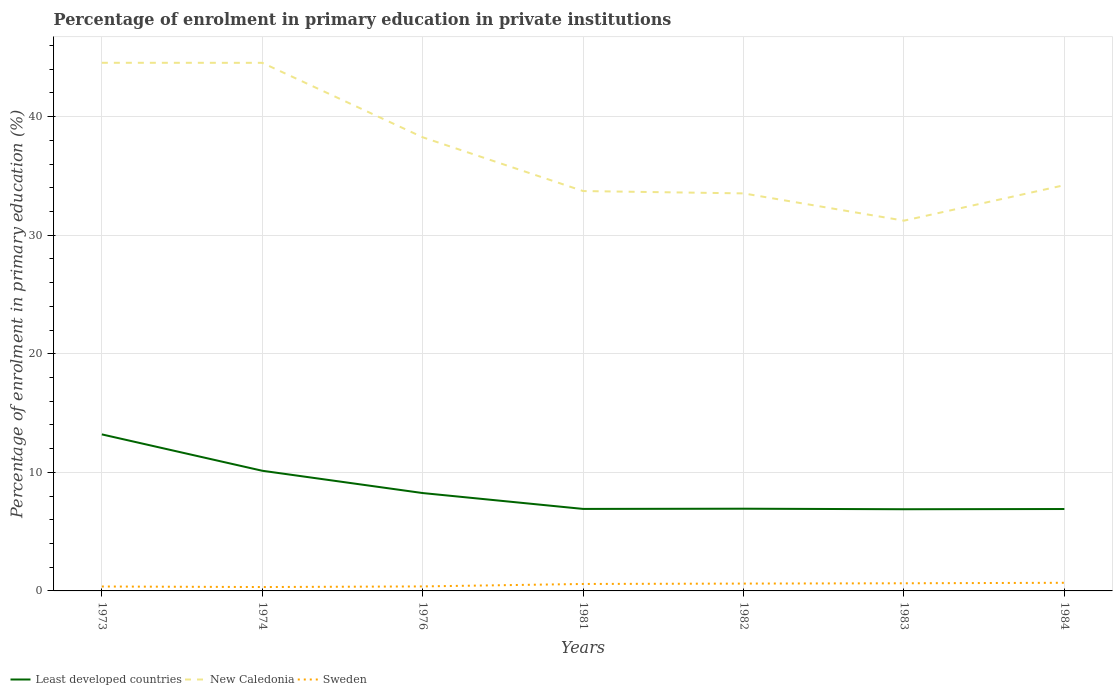Does the line corresponding to Sweden intersect with the line corresponding to New Caledonia?
Offer a very short reply. No. Across all years, what is the maximum percentage of enrolment in primary education in Least developed countries?
Give a very brief answer. 6.89. What is the total percentage of enrolment in primary education in Least developed countries in the graph?
Ensure brevity in your answer.  6.31. What is the difference between the highest and the second highest percentage of enrolment in primary education in Least developed countries?
Offer a terse response. 6.31. Is the percentage of enrolment in primary education in Sweden strictly greater than the percentage of enrolment in primary education in New Caledonia over the years?
Offer a very short reply. Yes. What is the difference between two consecutive major ticks on the Y-axis?
Your response must be concise. 10. Does the graph contain grids?
Your response must be concise. Yes. How many legend labels are there?
Provide a succinct answer. 3. What is the title of the graph?
Provide a succinct answer. Percentage of enrolment in primary education in private institutions. What is the label or title of the Y-axis?
Your answer should be very brief. Percentage of enrolment in primary education (%). What is the Percentage of enrolment in primary education (%) in Least developed countries in 1973?
Give a very brief answer. 13.2. What is the Percentage of enrolment in primary education (%) of New Caledonia in 1973?
Offer a terse response. 44.54. What is the Percentage of enrolment in primary education (%) in Sweden in 1973?
Keep it short and to the point. 0.37. What is the Percentage of enrolment in primary education (%) in Least developed countries in 1974?
Your response must be concise. 10.13. What is the Percentage of enrolment in primary education (%) of New Caledonia in 1974?
Your response must be concise. 44.54. What is the Percentage of enrolment in primary education (%) of Sweden in 1974?
Ensure brevity in your answer.  0.33. What is the Percentage of enrolment in primary education (%) in Least developed countries in 1976?
Make the answer very short. 8.25. What is the Percentage of enrolment in primary education (%) in New Caledonia in 1976?
Give a very brief answer. 38.26. What is the Percentage of enrolment in primary education (%) in Sweden in 1976?
Your answer should be compact. 0.38. What is the Percentage of enrolment in primary education (%) of Least developed countries in 1981?
Your answer should be compact. 6.92. What is the Percentage of enrolment in primary education (%) of New Caledonia in 1981?
Your answer should be very brief. 33.72. What is the Percentage of enrolment in primary education (%) of Sweden in 1981?
Provide a succinct answer. 0.59. What is the Percentage of enrolment in primary education (%) of Least developed countries in 1982?
Make the answer very short. 6.93. What is the Percentage of enrolment in primary education (%) in New Caledonia in 1982?
Provide a short and direct response. 33.53. What is the Percentage of enrolment in primary education (%) in Sweden in 1982?
Your answer should be very brief. 0.62. What is the Percentage of enrolment in primary education (%) of Least developed countries in 1983?
Ensure brevity in your answer.  6.89. What is the Percentage of enrolment in primary education (%) in New Caledonia in 1983?
Your answer should be very brief. 31.23. What is the Percentage of enrolment in primary education (%) of Sweden in 1983?
Provide a succinct answer. 0.64. What is the Percentage of enrolment in primary education (%) of Least developed countries in 1984?
Offer a very short reply. 6.91. What is the Percentage of enrolment in primary education (%) of New Caledonia in 1984?
Ensure brevity in your answer.  34.22. What is the Percentage of enrolment in primary education (%) in Sweden in 1984?
Your response must be concise. 0.69. Across all years, what is the maximum Percentage of enrolment in primary education (%) in Least developed countries?
Give a very brief answer. 13.2. Across all years, what is the maximum Percentage of enrolment in primary education (%) in New Caledonia?
Make the answer very short. 44.54. Across all years, what is the maximum Percentage of enrolment in primary education (%) of Sweden?
Offer a very short reply. 0.69. Across all years, what is the minimum Percentage of enrolment in primary education (%) in Least developed countries?
Provide a succinct answer. 6.89. Across all years, what is the minimum Percentage of enrolment in primary education (%) in New Caledonia?
Give a very brief answer. 31.23. Across all years, what is the minimum Percentage of enrolment in primary education (%) in Sweden?
Make the answer very short. 0.33. What is the total Percentage of enrolment in primary education (%) in Least developed countries in the graph?
Your answer should be very brief. 59.24. What is the total Percentage of enrolment in primary education (%) in New Caledonia in the graph?
Provide a short and direct response. 260.04. What is the total Percentage of enrolment in primary education (%) in Sweden in the graph?
Offer a very short reply. 3.62. What is the difference between the Percentage of enrolment in primary education (%) in Least developed countries in 1973 and that in 1974?
Your answer should be compact. 3.07. What is the difference between the Percentage of enrolment in primary education (%) of New Caledonia in 1973 and that in 1974?
Keep it short and to the point. 0. What is the difference between the Percentage of enrolment in primary education (%) of Sweden in 1973 and that in 1974?
Make the answer very short. 0.05. What is the difference between the Percentage of enrolment in primary education (%) of Least developed countries in 1973 and that in 1976?
Your answer should be very brief. 4.95. What is the difference between the Percentage of enrolment in primary education (%) in New Caledonia in 1973 and that in 1976?
Offer a terse response. 6.28. What is the difference between the Percentage of enrolment in primary education (%) in Sweden in 1973 and that in 1976?
Ensure brevity in your answer.  -0.01. What is the difference between the Percentage of enrolment in primary education (%) of Least developed countries in 1973 and that in 1981?
Your answer should be compact. 6.29. What is the difference between the Percentage of enrolment in primary education (%) of New Caledonia in 1973 and that in 1981?
Give a very brief answer. 10.82. What is the difference between the Percentage of enrolment in primary education (%) of Sweden in 1973 and that in 1981?
Your answer should be very brief. -0.21. What is the difference between the Percentage of enrolment in primary education (%) of Least developed countries in 1973 and that in 1982?
Make the answer very short. 6.27. What is the difference between the Percentage of enrolment in primary education (%) of New Caledonia in 1973 and that in 1982?
Provide a succinct answer. 11.01. What is the difference between the Percentage of enrolment in primary education (%) of Sweden in 1973 and that in 1982?
Give a very brief answer. -0.25. What is the difference between the Percentage of enrolment in primary education (%) of Least developed countries in 1973 and that in 1983?
Provide a short and direct response. 6.31. What is the difference between the Percentage of enrolment in primary education (%) of New Caledonia in 1973 and that in 1983?
Your answer should be compact. 13.31. What is the difference between the Percentage of enrolment in primary education (%) of Sweden in 1973 and that in 1983?
Offer a very short reply. -0.27. What is the difference between the Percentage of enrolment in primary education (%) of Least developed countries in 1973 and that in 1984?
Your answer should be compact. 6.29. What is the difference between the Percentage of enrolment in primary education (%) of New Caledonia in 1973 and that in 1984?
Provide a succinct answer. 10.32. What is the difference between the Percentage of enrolment in primary education (%) in Sweden in 1973 and that in 1984?
Ensure brevity in your answer.  -0.31. What is the difference between the Percentage of enrolment in primary education (%) in Least developed countries in 1974 and that in 1976?
Offer a very short reply. 1.88. What is the difference between the Percentage of enrolment in primary education (%) of New Caledonia in 1974 and that in 1976?
Offer a terse response. 6.28. What is the difference between the Percentage of enrolment in primary education (%) of Sweden in 1974 and that in 1976?
Your answer should be very brief. -0.05. What is the difference between the Percentage of enrolment in primary education (%) of Least developed countries in 1974 and that in 1981?
Ensure brevity in your answer.  3.22. What is the difference between the Percentage of enrolment in primary education (%) of New Caledonia in 1974 and that in 1981?
Offer a terse response. 10.81. What is the difference between the Percentage of enrolment in primary education (%) in Sweden in 1974 and that in 1981?
Your response must be concise. -0.26. What is the difference between the Percentage of enrolment in primary education (%) in Least developed countries in 1974 and that in 1982?
Make the answer very short. 3.2. What is the difference between the Percentage of enrolment in primary education (%) of New Caledonia in 1974 and that in 1982?
Give a very brief answer. 11.01. What is the difference between the Percentage of enrolment in primary education (%) of Sweden in 1974 and that in 1982?
Offer a terse response. -0.29. What is the difference between the Percentage of enrolment in primary education (%) of Least developed countries in 1974 and that in 1983?
Provide a succinct answer. 3.25. What is the difference between the Percentage of enrolment in primary education (%) of New Caledonia in 1974 and that in 1983?
Ensure brevity in your answer.  13.31. What is the difference between the Percentage of enrolment in primary education (%) of Sweden in 1974 and that in 1983?
Provide a succinct answer. -0.32. What is the difference between the Percentage of enrolment in primary education (%) of Least developed countries in 1974 and that in 1984?
Your response must be concise. 3.23. What is the difference between the Percentage of enrolment in primary education (%) in New Caledonia in 1974 and that in 1984?
Offer a terse response. 10.32. What is the difference between the Percentage of enrolment in primary education (%) in Sweden in 1974 and that in 1984?
Provide a succinct answer. -0.36. What is the difference between the Percentage of enrolment in primary education (%) of Least developed countries in 1976 and that in 1981?
Offer a very short reply. 1.34. What is the difference between the Percentage of enrolment in primary education (%) in New Caledonia in 1976 and that in 1981?
Offer a very short reply. 4.54. What is the difference between the Percentage of enrolment in primary education (%) in Sweden in 1976 and that in 1981?
Give a very brief answer. -0.21. What is the difference between the Percentage of enrolment in primary education (%) in Least developed countries in 1976 and that in 1982?
Provide a short and direct response. 1.32. What is the difference between the Percentage of enrolment in primary education (%) of New Caledonia in 1976 and that in 1982?
Offer a very short reply. 4.73. What is the difference between the Percentage of enrolment in primary education (%) of Sweden in 1976 and that in 1982?
Make the answer very short. -0.24. What is the difference between the Percentage of enrolment in primary education (%) of Least developed countries in 1976 and that in 1983?
Give a very brief answer. 1.36. What is the difference between the Percentage of enrolment in primary education (%) in New Caledonia in 1976 and that in 1983?
Your response must be concise. 7.03. What is the difference between the Percentage of enrolment in primary education (%) of Sweden in 1976 and that in 1983?
Provide a succinct answer. -0.26. What is the difference between the Percentage of enrolment in primary education (%) of Least developed countries in 1976 and that in 1984?
Offer a terse response. 1.35. What is the difference between the Percentage of enrolment in primary education (%) in New Caledonia in 1976 and that in 1984?
Provide a succinct answer. 4.04. What is the difference between the Percentage of enrolment in primary education (%) of Sweden in 1976 and that in 1984?
Provide a short and direct response. -0.31. What is the difference between the Percentage of enrolment in primary education (%) in Least developed countries in 1981 and that in 1982?
Keep it short and to the point. -0.02. What is the difference between the Percentage of enrolment in primary education (%) of New Caledonia in 1981 and that in 1982?
Offer a terse response. 0.2. What is the difference between the Percentage of enrolment in primary education (%) of Sweden in 1981 and that in 1982?
Your answer should be very brief. -0.03. What is the difference between the Percentage of enrolment in primary education (%) of Least developed countries in 1981 and that in 1983?
Your answer should be very brief. 0.03. What is the difference between the Percentage of enrolment in primary education (%) in New Caledonia in 1981 and that in 1983?
Offer a terse response. 2.5. What is the difference between the Percentage of enrolment in primary education (%) in Sweden in 1981 and that in 1983?
Offer a very short reply. -0.06. What is the difference between the Percentage of enrolment in primary education (%) of Least developed countries in 1981 and that in 1984?
Offer a terse response. 0.01. What is the difference between the Percentage of enrolment in primary education (%) of New Caledonia in 1981 and that in 1984?
Offer a very short reply. -0.5. What is the difference between the Percentage of enrolment in primary education (%) of Sweden in 1981 and that in 1984?
Your answer should be compact. -0.1. What is the difference between the Percentage of enrolment in primary education (%) in Least developed countries in 1982 and that in 1983?
Offer a terse response. 0.04. What is the difference between the Percentage of enrolment in primary education (%) of New Caledonia in 1982 and that in 1983?
Keep it short and to the point. 2.3. What is the difference between the Percentage of enrolment in primary education (%) in Sweden in 1982 and that in 1983?
Your answer should be very brief. -0.03. What is the difference between the Percentage of enrolment in primary education (%) of Least developed countries in 1982 and that in 1984?
Offer a very short reply. 0.03. What is the difference between the Percentage of enrolment in primary education (%) of New Caledonia in 1982 and that in 1984?
Your response must be concise. -0.69. What is the difference between the Percentage of enrolment in primary education (%) in Sweden in 1982 and that in 1984?
Your answer should be very brief. -0.07. What is the difference between the Percentage of enrolment in primary education (%) of Least developed countries in 1983 and that in 1984?
Give a very brief answer. -0.02. What is the difference between the Percentage of enrolment in primary education (%) in New Caledonia in 1983 and that in 1984?
Your response must be concise. -2.99. What is the difference between the Percentage of enrolment in primary education (%) of Sweden in 1983 and that in 1984?
Offer a terse response. -0.04. What is the difference between the Percentage of enrolment in primary education (%) of Least developed countries in 1973 and the Percentage of enrolment in primary education (%) of New Caledonia in 1974?
Keep it short and to the point. -31.34. What is the difference between the Percentage of enrolment in primary education (%) in Least developed countries in 1973 and the Percentage of enrolment in primary education (%) in Sweden in 1974?
Provide a short and direct response. 12.87. What is the difference between the Percentage of enrolment in primary education (%) in New Caledonia in 1973 and the Percentage of enrolment in primary education (%) in Sweden in 1974?
Make the answer very short. 44.21. What is the difference between the Percentage of enrolment in primary education (%) of Least developed countries in 1973 and the Percentage of enrolment in primary education (%) of New Caledonia in 1976?
Your response must be concise. -25.06. What is the difference between the Percentage of enrolment in primary education (%) in Least developed countries in 1973 and the Percentage of enrolment in primary education (%) in Sweden in 1976?
Provide a short and direct response. 12.82. What is the difference between the Percentage of enrolment in primary education (%) in New Caledonia in 1973 and the Percentage of enrolment in primary education (%) in Sweden in 1976?
Offer a very short reply. 44.16. What is the difference between the Percentage of enrolment in primary education (%) of Least developed countries in 1973 and the Percentage of enrolment in primary education (%) of New Caledonia in 1981?
Your answer should be compact. -20.52. What is the difference between the Percentage of enrolment in primary education (%) in Least developed countries in 1973 and the Percentage of enrolment in primary education (%) in Sweden in 1981?
Offer a terse response. 12.62. What is the difference between the Percentage of enrolment in primary education (%) of New Caledonia in 1973 and the Percentage of enrolment in primary education (%) of Sweden in 1981?
Provide a succinct answer. 43.95. What is the difference between the Percentage of enrolment in primary education (%) of Least developed countries in 1973 and the Percentage of enrolment in primary education (%) of New Caledonia in 1982?
Offer a terse response. -20.32. What is the difference between the Percentage of enrolment in primary education (%) of Least developed countries in 1973 and the Percentage of enrolment in primary education (%) of Sweden in 1982?
Give a very brief answer. 12.58. What is the difference between the Percentage of enrolment in primary education (%) of New Caledonia in 1973 and the Percentage of enrolment in primary education (%) of Sweden in 1982?
Your response must be concise. 43.92. What is the difference between the Percentage of enrolment in primary education (%) in Least developed countries in 1973 and the Percentage of enrolment in primary education (%) in New Caledonia in 1983?
Offer a very short reply. -18.02. What is the difference between the Percentage of enrolment in primary education (%) of Least developed countries in 1973 and the Percentage of enrolment in primary education (%) of Sweden in 1983?
Your response must be concise. 12.56. What is the difference between the Percentage of enrolment in primary education (%) in New Caledonia in 1973 and the Percentage of enrolment in primary education (%) in Sweden in 1983?
Offer a terse response. 43.9. What is the difference between the Percentage of enrolment in primary education (%) in Least developed countries in 1973 and the Percentage of enrolment in primary education (%) in New Caledonia in 1984?
Your answer should be very brief. -21.02. What is the difference between the Percentage of enrolment in primary education (%) of Least developed countries in 1973 and the Percentage of enrolment in primary education (%) of Sweden in 1984?
Offer a very short reply. 12.52. What is the difference between the Percentage of enrolment in primary education (%) of New Caledonia in 1973 and the Percentage of enrolment in primary education (%) of Sweden in 1984?
Provide a succinct answer. 43.86. What is the difference between the Percentage of enrolment in primary education (%) of Least developed countries in 1974 and the Percentage of enrolment in primary education (%) of New Caledonia in 1976?
Your answer should be compact. -28.12. What is the difference between the Percentage of enrolment in primary education (%) of Least developed countries in 1974 and the Percentage of enrolment in primary education (%) of Sweden in 1976?
Make the answer very short. 9.76. What is the difference between the Percentage of enrolment in primary education (%) in New Caledonia in 1974 and the Percentage of enrolment in primary education (%) in Sweden in 1976?
Make the answer very short. 44.16. What is the difference between the Percentage of enrolment in primary education (%) in Least developed countries in 1974 and the Percentage of enrolment in primary education (%) in New Caledonia in 1981?
Give a very brief answer. -23.59. What is the difference between the Percentage of enrolment in primary education (%) of Least developed countries in 1974 and the Percentage of enrolment in primary education (%) of Sweden in 1981?
Your answer should be compact. 9.55. What is the difference between the Percentage of enrolment in primary education (%) in New Caledonia in 1974 and the Percentage of enrolment in primary education (%) in Sweden in 1981?
Keep it short and to the point. 43.95. What is the difference between the Percentage of enrolment in primary education (%) of Least developed countries in 1974 and the Percentage of enrolment in primary education (%) of New Caledonia in 1982?
Offer a very short reply. -23.39. What is the difference between the Percentage of enrolment in primary education (%) of Least developed countries in 1974 and the Percentage of enrolment in primary education (%) of Sweden in 1982?
Make the answer very short. 9.52. What is the difference between the Percentage of enrolment in primary education (%) in New Caledonia in 1974 and the Percentage of enrolment in primary education (%) in Sweden in 1982?
Your response must be concise. 43.92. What is the difference between the Percentage of enrolment in primary education (%) of Least developed countries in 1974 and the Percentage of enrolment in primary education (%) of New Caledonia in 1983?
Provide a succinct answer. -21.09. What is the difference between the Percentage of enrolment in primary education (%) in Least developed countries in 1974 and the Percentage of enrolment in primary education (%) in Sweden in 1983?
Offer a terse response. 9.49. What is the difference between the Percentage of enrolment in primary education (%) of New Caledonia in 1974 and the Percentage of enrolment in primary education (%) of Sweden in 1983?
Offer a terse response. 43.89. What is the difference between the Percentage of enrolment in primary education (%) of Least developed countries in 1974 and the Percentage of enrolment in primary education (%) of New Caledonia in 1984?
Offer a very short reply. -24.08. What is the difference between the Percentage of enrolment in primary education (%) in Least developed countries in 1974 and the Percentage of enrolment in primary education (%) in Sweden in 1984?
Offer a very short reply. 9.45. What is the difference between the Percentage of enrolment in primary education (%) in New Caledonia in 1974 and the Percentage of enrolment in primary education (%) in Sweden in 1984?
Give a very brief answer. 43.85. What is the difference between the Percentage of enrolment in primary education (%) in Least developed countries in 1976 and the Percentage of enrolment in primary education (%) in New Caledonia in 1981?
Provide a short and direct response. -25.47. What is the difference between the Percentage of enrolment in primary education (%) of Least developed countries in 1976 and the Percentage of enrolment in primary education (%) of Sweden in 1981?
Give a very brief answer. 7.67. What is the difference between the Percentage of enrolment in primary education (%) of New Caledonia in 1976 and the Percentage of enrolment in primary education (%) of Sweden in 1981?
Your answer should be very brief. 37.67. What is the difference between the Percentage of enrolment in primary education (%) in Least developed countries in 1976 and the Percentage of enrolment in primary education (%) in New Caledonia in 1982?
Give a very brief answer. -25.27. What is the difference between the Percentage of enrolment in primary education (%) in Least developed countries in 1976 and the Percentage of enrolment in primary education (%) in Sweden in 1982?
Give a very brief answer. 7.63. What is the difference between the Percentage of enrolment in primary education (%) of New Caledonia in 1976 and the Percentage of enrolment in primary education (%) of Sweden in 1982?
Your response must be concise. 37.64. What is the difference between the Percentage of enrolment in primary education (%) of Least developed countries in 1976 and the Percentage of enrolment in primary education (%) of New Caledonia in 1983?
Offer a terse response. -22.97. What is the difference between the Percentage of enrolment in primary education (%) in Least developed countries in 1976 and the Percentage of enrolment in primary education (%) in Sweden in 1983?
Your answer should be compact. 7.61. What is the difference between the Percentage of enrolment in primary education (%) in New Caledonia in 1976 and the Percentage of enrolment in primary education (%) in Sweden in 1983?
Offer a very short reply. 37.62. What is the difference between the Percentage of enrolment in primary education (%) of Least developed countries in 1976 and the Percentage of enrolment in primary education (%) of New Caledonia in 1984?
Provide a succinct answer. -25.97. What is the difference between the Percentage of enrolment in primary education (%) of Least developed countries in 1976 and the Percentage of enrolment in primary education (%) of Sweden in 1984?
Make the answer very short. 7.57. What is the difference between the Percentage of enrolment in primary education (%) of New Caledonia in 1976 and the Percentage of enrolment in primary education (%) of Sweden in 1984?
Keep it short and to the point. 37.57. What is the difference between the Percentage of enrolment in primary education (%) of Least developed countries in 1981 and the Percentage of enrolment in primary education (%) of New Caledonia in 1982?
Provide a short and direct response. -26.61. What is the difference between the Percentage of enrolment in primary education (%) of Least developed countries in 1981 and the Percentage of enrolment in primary education (%) of Sweden in 1982?
Offer a terse response. 6.3. What is the difference between the Percentage of enrolment in primary education (%) of New Caledonia in 1981 and the Percentage of enrolment in primary education (%) of Sweden in 1982?
Offer a terse response. 33.11. What is the difference between the Percentage of enrolment in primary education (%) in Least developed countries in 1981 and the Percentage of enrolment in primary education (%) in New Caledonia in 1983?
Your answer should be very brief. -24.31. What is the difference between the Percentage of enrolment in primary education (%) of Least developed countries in 1981 and the Percentage of enrolment in primary education (%) of Sweden in 1983?
Ensure brevity in your answer.  6.27. What is the difference between the Percentage of enrolment in primary education (%) of New Caledonia in 1981 and the Percentage of enrolment in primary education (%) of Sweden in 1983?
Provide a short and direct response. 33.08. What is the difference between the Percentage of enrolment in primary education (%) in Least developed countries in 1981 and the Percentage of enrolment in primary education (%) in New Caledonia in 1984?
Give a very brief answer. -27.3. What is the difference between the Percentage of enrolment in primary education (%) in Least developed countries in 1981 and the Percentage of enrolment in primary education (%) in Sweden in 1984?
Your answer should be compact. 6.23. What is the difference between the Percentage of enrolment in primary education (%) of New Caledonia in 1981 and the Percentage of enrolment in primary education (%) of Sweden in 1984?
Your answer should be very brief. 33.04. What is the difference between the Percentage of enrolment in primary education (%) of Least developed countries in 1982 and the Percentage of enrolment in primary education (%) of New Caledonia in 1983?
Offer a very short reply. -24.29. What is the difference between the Percentage of enrolment in primary education (%) of Least developed countries in 1982 and the Percentage of enrolment in primary education (%) of Sweden in 1983?
Ensure brevity in your answer.  6.29. What is the difference between the Percentage of enrolment in primary education (%) in New Caledonia in 1982 and the Percentage of enrolment in primary education (%) in Sweden in 1983?
Make the answer very short. 32.88. What is the difference between the Percentage of enrolment in primary education (%) in Least developed countries in 1982 and the Percentage of enrolment in primary education (%) in New Caledonia in 1984?
Offer a very short reply. -27.29. What is the difference between the Percentage of enrolment in primary education (%) in Least developed countries in 1982 and the Percentage of enrolment in primary education (%) in Sweden in 1984?
Your answer should be compact. 6.25. What is the difference between the Percentage of enrolment in primary education (%) of New Caledonia in 1982 and the Percentage of enrolment in primary education (%) of Sweden in 1984?
Provide a succinct answer. 32.84. What is the difference between the Percentage of enrolment in primary education (%) in Least developed countries in 1983 and the Percentage of enrolment in primary education (%) in New Caledonia in 1984?
Offer a very short reply. -27.33. What is the difference between the Percentage of enrolment in primary education (%) of Least developed countries in 1983 and the Percentage of enrolment in primary education (%) of Sweden in 1984?
Ensure brevity in your answer.  6.2. What is the difference between the Percentage of enrolment in primary education (%) of New Caledonia in 1983 and the Percentage of enrolment in primary education (%) of Sweden in 1984?
Your answer should be compact. 30.54. What is the average Percentage of enrolment in primary education (%) in Least developed countries per year?
Give a very brief answer. 8.46. What is the average Percentage of enrolment in primary education (%) of New Caledonia per year?
Your response must be concise. 37.15. What is the average Percentage of enrolment in primary education (%) of Sweden per year?
Provide a short and direct response. 0.52. In the year 1973, what is the difference between the Percentage of enrolment in primary education (%) in Least developed countries and Percentage of enrolment in primary education (%) in New Caledonia?
Keep it short and to the point. -31.34. In the year 1973, what is the difference between the Percentage of enrolment in primary education (%) of Least developed countries and Percentage of enrolment in primary education (%) of Sweden?
Make the answer very short. 12.83. In the year 1973, what is the difference between the Percentage of enrolment in primary education (%) of New Caledonia and Percentage of enrolment in primary education (%) of Sweden?
Keep it short and to the point. 44.17. In the year 1974, what is the difference between the Percentage of enrolment in primary education (%) of Least developed countries and Percentage of enrolment in primary education (%) of New Caledonia?
Your response must be concise. -34.4. In the year 1974, what is the difference between the Percentage of enrolment in primary education (%) in Least developed countries and Percentage of enrolment in primary education (%) in Sweden?
Keep it short and to the point. 9.81. In the year 1974, what is the difference between the Percentage of enrolment in primary education (%) in New Caledonia and Percentage of enrolment in primary education (%) in Sweden?
Make the answer very short. 44.21. In the year 1976, what is the difference between the Percentage of enrolment in primary education (%) in Least developed countries and Percentage of enrolment in primary education (%) in New Caledonia?
Your response must be concise. -30.01. In the year 1976, what is the difference between the Percentage of enrolment in primary education (%) of Least developed countries and Percentage of enrolment in primary education (%) of Sweden?
Keep it short and to the point. 7.87. In the year 1976, what is the difference between the Percentage of enrolment in primary education (%) of New Caledonia and Percentage of enrolment in primary education (%) of Sweden?
Offer a very short reply. 37.88. In the year 1981, what is the difference between the Percentage of enrolment in primary education (%) of Least developed countries and Percentage of enrolment in primary education (%) of New Caledonia?
Offer a very short reply. -26.81. In the year 1981, what is the difference between the Percentage of enrolment in primary education (%) in Least developed countries and Percentage of enrolment in primary education (%) in Sweden?
Make the answer very short. 6.33. In the year 1981, what is the difference between the Percentage of enrolment in primary education (%) in New Caledonia and Percentage of enrolment in primary education (%) in Sweden?
Make the answer very short. 33.14. In the year 1982, what is the difference between the Percentage of enrolment in primary education (%) in Least developed countries and Percentage of enrolment in primary education (%) in New Caledonia?
Your answer should be very brief. -26.59. In the year 1982, what is the difference between the Percentage of enrolment in primary education (%) in Least developed countries and Percentage of enrolment in primary education (%) in Sweden?
Offer a very short reply. 6.31. In the year 1982, what is the difference between the Percentage of enrolment in primary education (%) of New Caledonia and Percentage of enrolment in primary education (%) of Sweden?
Offer a terse response. 32.91. In the year 1983, what is the difference between the Percentage of enrolment in primary education (%) of Least developed countries and Percentage of enrolment in primary education (%) of New Caledonia?
Provide a short and direct response. -24.34. In the year 1983, what is the difference between the Percentage of enrolment in primary education (%) in Least developed countries and Percentage of enrolment in primary education (%) in Sweden?
Offer a very short reply. 6.25. In the year 1983, what is the difference between the Percentage of enrolment in primary education (%) of New Caledonia and Percentage of enrolment in primary education (%) of Sweden?
Keep it short and to the point. 30.58. In the year 1984, what is the difference between the Percentage of enrolment in primary education (%) in Least developed countries and Percentage of enrolment in primary education (%) in New Caledonia?
Provide a succinct answer. -27.31. In the year 1984, what is the difference between the Percentage of enrolment in primary education (%) in Least developed countries and Percentage of enrolment in primary education (%) in Sweden?
Provide a succinct answer. 6.22. In the year 1984, what is the difference between the Percentage of enrolment in primary education (%) of New Caledonia and Percentage of enrolment in primary education (%) of Sweden?
Provide a short and direct response. 33.53. What is the ratio of the Percentage of enrolment in primary education (%) of Least developed countries in 1973 to that in 1974?
Keep it short and to the point. 1.3. What is the ratio of the Percentage of enrolment in primary education (%) of Sweden in 1973 to that in 1974?
Keep it short and to the point. 1.14. What is the ratio of the Percentage of enrolment in primary education (%) of Least developed countries in 1973 to that in 1976?
Your response must be concise. 1.6. What is the ratio of the Percentage of enrolment in primary education (%) of New Caledonia in 1973 to that in 1976?
Ensure brevity in your answer.  1.16. What is the ratio of the Percentage of enrolment in primary education (%) of Sweden in 1973 to that in 1976?
Keep it short and to the point. 0.98. What is the ratio of the Percentage of enrolment in primary education (%) of Least developed countries in 1973 to that in 1981?
Your response must be concise. 1.91. What is the ratio of the Percentage of enrolment in primary education (%) of New Caledonia in 1973 to that in 1981?
Ensure brevity in your answer.  1.32. What is the ratio of the Percentage of enrolment in primary education (%) of Sweden in 1973 to that in 1981?
Offer a very short reply. 0.64. What is the ratio of the Percentage of enrolment in primary education (%) in Least developed countries in 1973 to that in 1982?
Make the answer very short. 1.9. What is the ratio of the Percentage of enrolment in primary education (%) in New Caledonia in 1973 to that in 1982?
Ensure brevity in your answer.  1.33. What is the ratio of the Percentage of enrolment in primary education (%) in Sweden in 1973 to that in 1982?
Make the answer very short. 0.6. What is the ratio of the Percentage of enrolment in primary education (%) of Least developed countries in 1973 to that in 1983?
Ensure brevity in your answer.  1.92. What is the ratio of the Percentage of enrolment in primary education (%) of New Caledonia in 1973 to that in 1983?
Provide a short and direct response. 1.43. What is the ratio of the Percentage of enrolment in primary education (%) of Sweden in 1973 to that in 1983?
Ensure brevity in your answer.  0.58. What is the ratio of the Percentage of enrolment in primary education (%) of Least developed countries in 1973 to that in 1984?
Your answer should be very brief. 1.91. What is the ratio of the Percentage of enrolment in primary education (%) of New Caledonia in 1973 to that in 1984?
Provide a succinct answer. 1.3. What is the ratio of the Percentage of enrolment in primary education (%) in Sweden in 1973 to that in 1984?
Provide a short and direct response. 0.54. What is the ratio of the Percentage of enrolment in primary education (%) in Least developed countries in 1974 to that in 1976?
Your response must be concise. 1.23. What is the ratio of the Percentage of enrolment in primary education (%) of New Caledonia in 1974 to that in 1976?
Your answer should be very brief. 1.16. What is the ratio of the Percentage of enrolment in primary education (%) in Sweden in 1974 to that in 1976?
Offer a very short reply. 0.86. What is the ratio of the Percentage of enrolment in primary education (%) in Least developed countries in 1974 to that in 1981?
Provide a short and direct response. 1.47. What is the ratio of the Percentage of enrolment in primary education (%) in New Caledonia in 1974 to that in 1981?
Your answer should be compact. 1.32. What is the ratio of the Percentage of enrolment in primary education (%) in Sweden in 1974 to that in 1981?
Your answer should be compact. 0.56. What is the ratio of the Percentage of enrolment in primary education (%) in Least developed countries in 1974 to that in 1982?
Keep it short and to the point. 1.46. What is the ratio of the Percentage of enrolment in primary education (%) in New Caledonia in 1974 to that in 1982?
Provide a short and direct response. 1.33. What is the ratio of the Percentage of enrolment in primary education (%) in Sweden in 1974 to that in 1982?
Offer a very short reply. 0.53. What is the ratio of the Percentage of enrolment in primary education (%) in Least developed countries in 1974 to that in 1983?
Give a very brief answer. 1.47. What is the ratio of the Percentage of enrolment in primary education (%) in New Caledonia in 1974 to that in 1983?
Give a very brief answer. 1.43. What is the ratio of the Percentage of enrolment in primary education (%) in Sweden in 1974 to that in 1983?
Make the answer very short. 0.51. What is the ratio of the Percentage of enrolment in primary education (%) of Least developed countries in 1974 to that in 1984?
Offer a very short reply. 1.47. What is the ratio of the Percentage of enrolment in primary education (%) of New Caledonia in 1974 to that in 1984?
Provide a succinct answer. 1.3. What is the ratio of the Percentage of enrolment in primary education (%) of Sweden in 1974 to that in 1984?
Provide a short and direct response. 0.48. What is the ratio of the Percentage of enrolment in primary education (%) in Least developed countries in 1976 to that in 1981?
Ensure brevity in your answer.  1.19. What is the ratio of the Percentage of enrolment in primary education (%) in New Caledonia in 1976 to that in 1981?
Offer a very short reply. 1.13. What is the ratio of the Percentage of enrolment in primary education (%) of Sweden in 1976 to that in 1981?
Offer a terse response. 0.65. What is the ratio of the Percentage of enrolment in primary education (%) in Least developed countries in 1976 to that in 1982?
Give a very brief answer. 1.19. What is the ratio of the Percentage of enrolment in primary education (%) in New Caledonia in 1976 to that in 1982?
Your answer should be very brief. 1.14. What is the ratio of the Percentage of enrolment in primary education (%) of Sweden in 1976 to that in 1982?
Provide a succinct answer. 0.61. What is the ratio of the Percentage of enrolment in primary education (%) of Least developed countries in 1976 to that in 1983?
Provide a short and direct response. 1.2. What is the ratio of the Percentage of enrolment in primary education (%) in New Caledonia in 1976 to that in 1983?
Keep it short and to the point. 1.23. What is the ratio of the Percentage of enrolment in primary education (%) in Sweden in 1976 to that in 1983?
Offer a terse response. 0.59. What is the ratio of the Percentage of enrolment in primary education (%) in Least developed countries in 1976 to that in 1984?
Provide a short and direct response. 1.19. What is the ratio of the Percentage of enrolment in primary education (%) in New Caledonia in 1976 to that in 1984?
Give a very brief answer. 1.12. What is the ratio of the Percentage of enrolment in primary education (%) in Sweden in 1976 to that in 1984?
Your answer should be very brief. 0.55. What is the ratio of the Percentage of enrolment in primary education (%) in New Caledonia in 1981 to that in 1982?
Your answer should be compact. 1.01. What is the ratio of the Percentage of enrolment in primary education (%) in Sweden in 1981 to that in 1982?
Provide a short and direct response. 0.95. What is the ratio of the Percentage of enrolment in primary education (%) of Least developed countries in 1981 to that in 1983?
Keep it short and to the point. 1. What is the ratio of the Percentage of enrolment in primary education (%) of Sweden in 1981 to that in 1983?
Your answer should be compact. 0.91. What is the ratio of the Percentage of enrolment in primary education (%) of Least developed countries in 1981 to that in 1984?
Keep it short and to the point. 1. What is the ratio of the Percentage of enrolment in primary education (%) in New Caledonia in 1981 to that in 1984?
Your answer should be compact. 0.99. What is the ratio of the Percentage of enrolment in primary education (%) of Sweden in 1981 to that in 1984?
Your response must be concise. 0.86. What is the ratio of the Percentage of enrolment in primary education (%) in Least developed countries in 1982 to that in 1983?
Ensure brevity in your answer.  1.01. What is the ratio of the Percentage of enrolment in primary education (%) in New Caledonia in 1982 to that in 1983?
Offer a very short reply. 1.07. What is the ratio of the Percentage of enrolment in primary education (%) in Sweden in 1982 to that in 1983?
Keep it short and to the point. 0.96. What is the ratio of the Percentage of enrolment in primary education (%) of New Caledonia in 1982 to that in 1984?
Provide a succinct answer. 0.98. What is the ratio of the Percentage of enrolment in primary education (%) in Sweden in 1982 to that in 1984?
Your answer should be compact. 0.9. What is the ratio of the Percentage of enrolment in primary education (%) in New Caledonia in 1983 to that in 1984?
Provide a short and direct response. 0.91. What is the ratio of the Percentage of enrolment in primary education (%) in Sweden in 1983 to that in 1984?
Your answer should be very brief. 0.94. What is the difference between the highest and the second highest Percentage of enrolment in primary education (%) of Least developed countries?
Your answer should be very brief. 3.07. What is the difference between the highest and the second highest Percentage of enrolment in primary education (%) in New Caledonia?
Make the answer very short. 0. What is the difference between the highest and the second highest Percentage of enrolment in primary education (%) of Sweden?
Give a very brief answer. 0.04. What is the difference between the highest and the lowest Percentage of enrolment in primary education (%) of Least developed countries?
Your response must be concise. 6.31. What is the difference between the highest and the lowest Percentage of enrolment in primary education (%) in New Caledonia?
Provide a short and direct response. 13.31. What is the difference between the highest and the lowest Percentage of enrolment in primary education (%) of Sweden?
Make the answer very short. 0.36. 